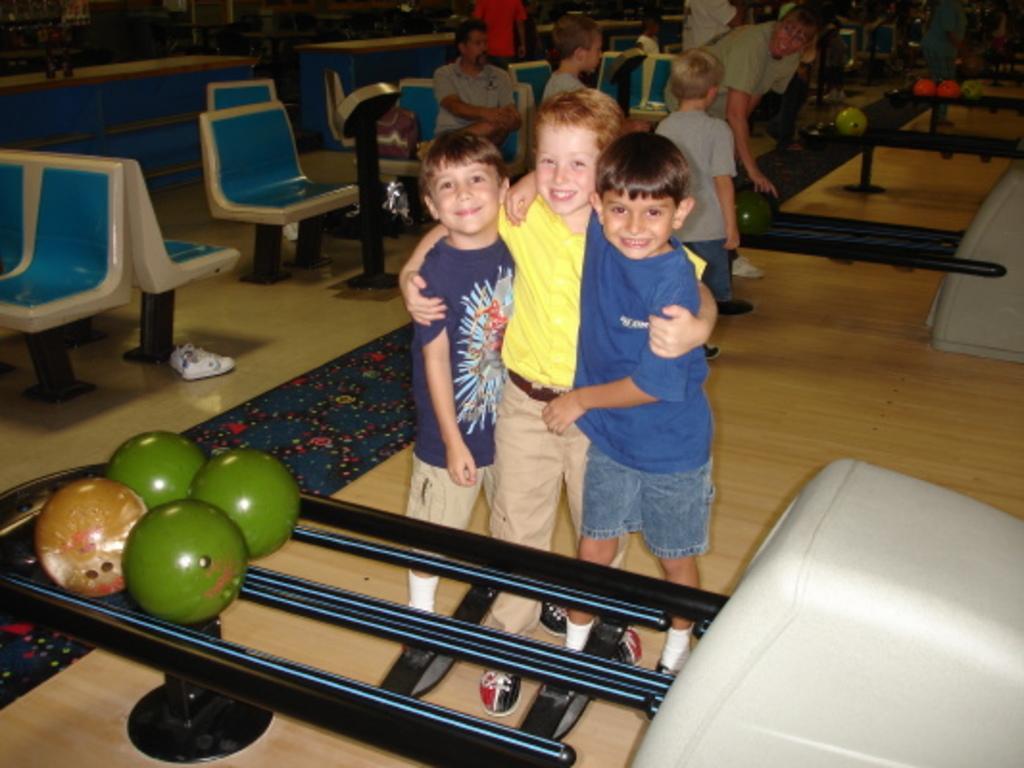Please provide a concise description of this image. In this image I can see three children are standing and I can see smile on their faces. Here I can see few balls and in the background I can see few people, few chairs and few more balls. I can see all of them are wearing t shirts and here I can see white colour shoes. 